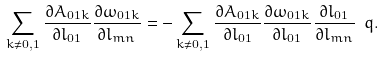Convert formula to latex. <formula><loc_0><loc_0><loc_500><loc_500>\sum _ { k \neq 0 , 1 } \frac { \partial A _ { 0 1 k } } { \partial l _ { 0 1 } } \frac { \partial \omega _ { 0 1 k } } { \partial l _ { m n } } = - \sum _ { k \neq 0 , 1 } \frac { \partial A _ { 0 1 k } } { \partial l _ { 0 1 } } \frac { \partial \omega _ { 0 1 k } } { \partial l _ { 0 1 } } \frac { \partial l _ { 0 1 } } { \partial l _ { m n } } \ q .</formula> 